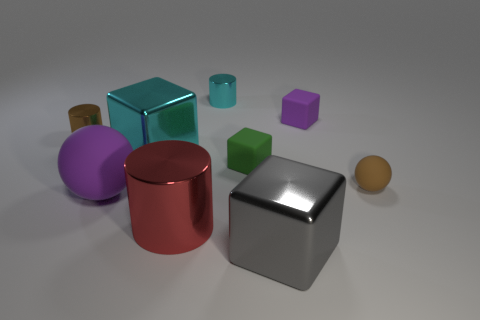Subtract all green matte cubes. How many cubes are left? 3 Add 1 purple rubber balls. How many objects exist? 10 Subtract all cyan cubes. How many cubes are left? 3 Subtract 1 blocks. How many blocks are left? 3 Subtract all blocks. How many objects are left? 5 Subtract all small red shiny balls. Subtract all large gray metal blocks. How many objects are left? 8 Add 9 green objects. How many green objects are left? 10 Add 8 cyan rubber cylinders. How many cyan rubber cylinders exist? 8 Subtract 1 brown cylinders. How many objects are left? 8 Subtract all cyan cubes. Subtract all brown balls. How many cubes are left? 3 